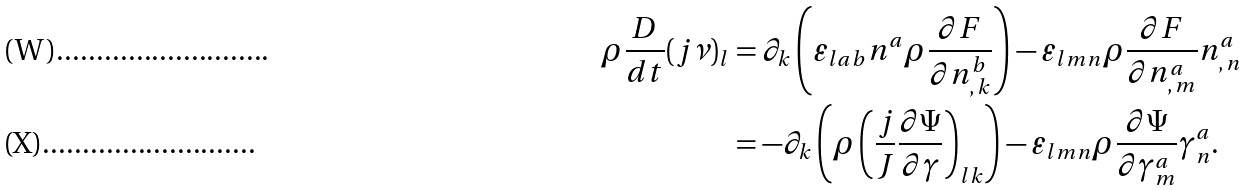<formula> <loc_0><loc_0><loc_500><loc_500>\rho \frac { D } { d t } ( j \nu ) _ { l } & = \partial _ { k } \left ( \varepsilon _ { l a b } n ^ { a } \rho \frac { \partial F } { \partial n ^ { b } _ { , \, k } } \right ) - \varepsilon _ { l m n } \rho \frac { \partial F } { \partial n ^ { a } _ { , \, m } } n ^ { a } _ { , \, n } \\ & = - \partial _ { k } \left ( \rho \left ( \frac { j } { J } \frac { \partial \Psi } { \partial \gamma } \right ) _ { l k } \right ) - \varepsilon _ { l m n } \rho \frac { \partial \Psi } { \partial \gamma ^ { a } _ { m } } \gamma ^ { a } _ { n } .</formula> 